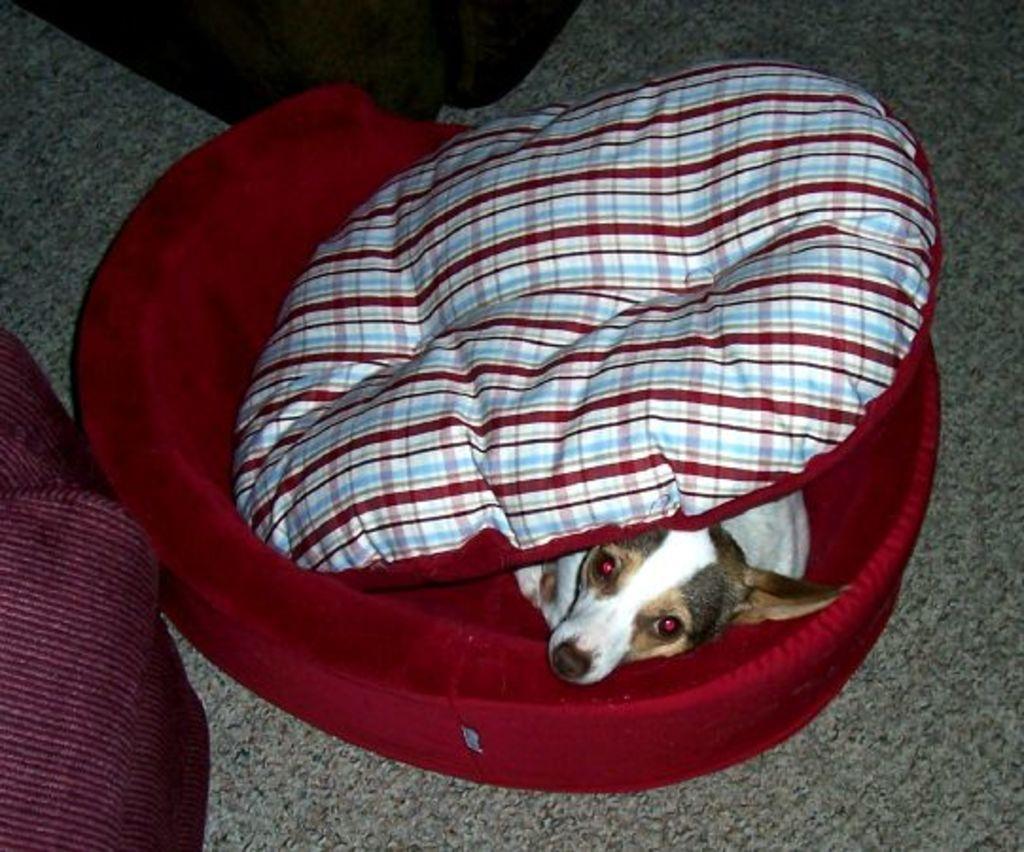In one or two sentences, can you explain what this image depicts? In this image I can see a dog sleeping on a small bed with a pillow on him on the floor. 